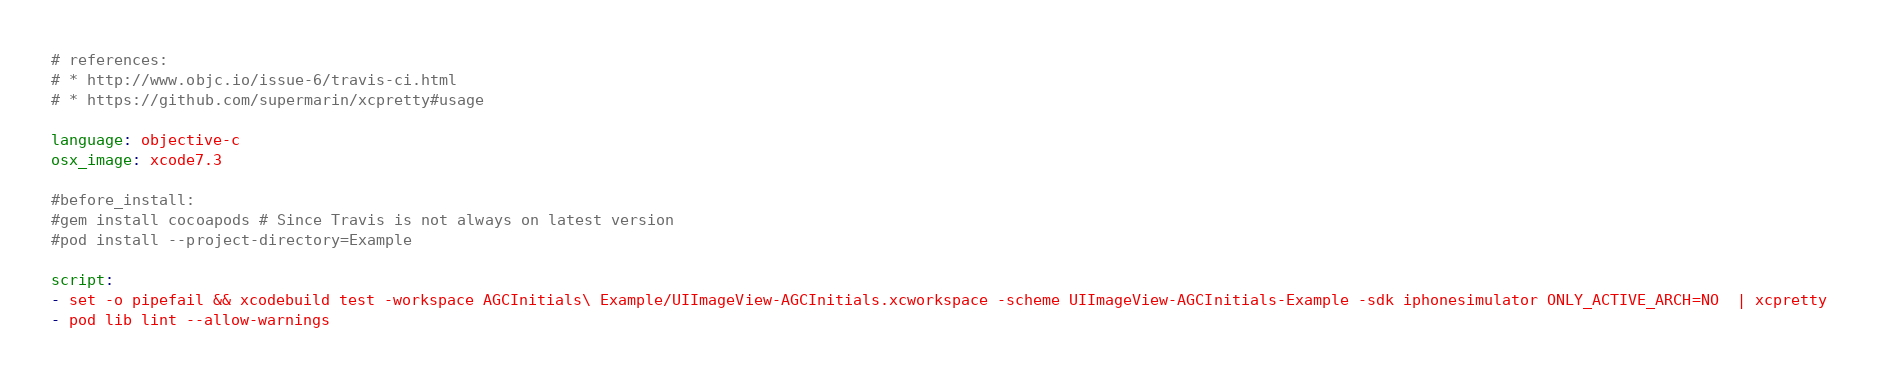Convert code to text. <code><loc_0><loc_0><loc_500><loc_500><_YAML_># references:
# * http://www.objc.io/issue-6/travis-ci.html
# * https://github.com/supermarin/xcpretty#usage

language: objective-c
osx_image: xcode7.3

#before_install:
#gem install cocoapods # Since Travis is not always on latest version
#pod install --project-directory=Example

script:
- set -o pipefail && xcodebuild test -workspace AGCInitials\ Example/UIImageView-AGCInitials.xcworkspace -scheme UIImageView-AGCInitials-Example -sdk iphonesimulator ONLY_ACTIVE_ARCH=NO  | xcpretty
- pod lib lint --allow-warnings
</code> 